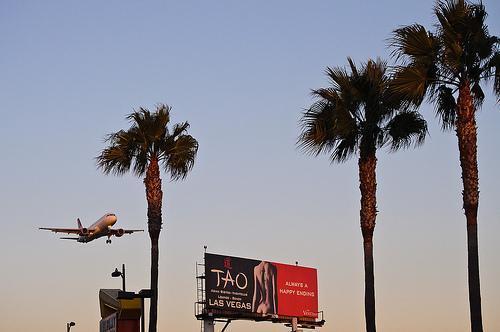How many planes are there?
Give a very brief answer. 1. 